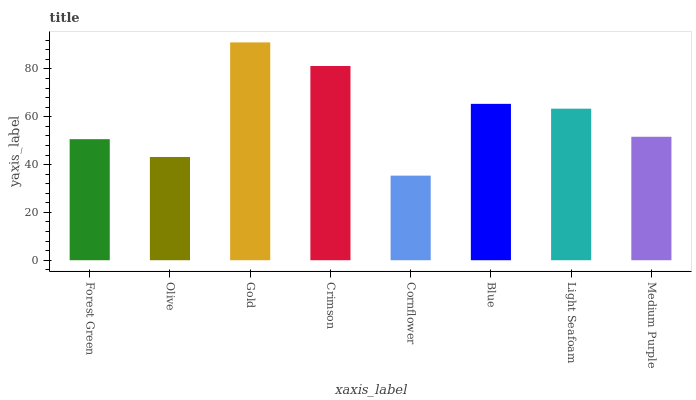Is Cornflower the minimum?
Answer yes or no. Yes. Is Gold the maximum?
Answer yes or no. Yes. Is Olive the minimum?
Answer yes or no. No. Is Olive the maximum?
Answer yes or no. No. Is Forest Green greater than Olive?
Answer yes or no. Yes. Is Olive less than Forest Green?
Answer yes or no. Yes. Is Olive greater than Forest Green?
Answer yes or no. No. Is Forest Green less than Olive?
Answer yes or no. No. Is Light Seafoam the high median?
Answer yes or no. Yes. Is Medium Purple the low median?
Answer yes or no. Yes. Is Crimson the high median?
Answer yes or no. No. Is Olive the low median?
Answer yes or no. No. 